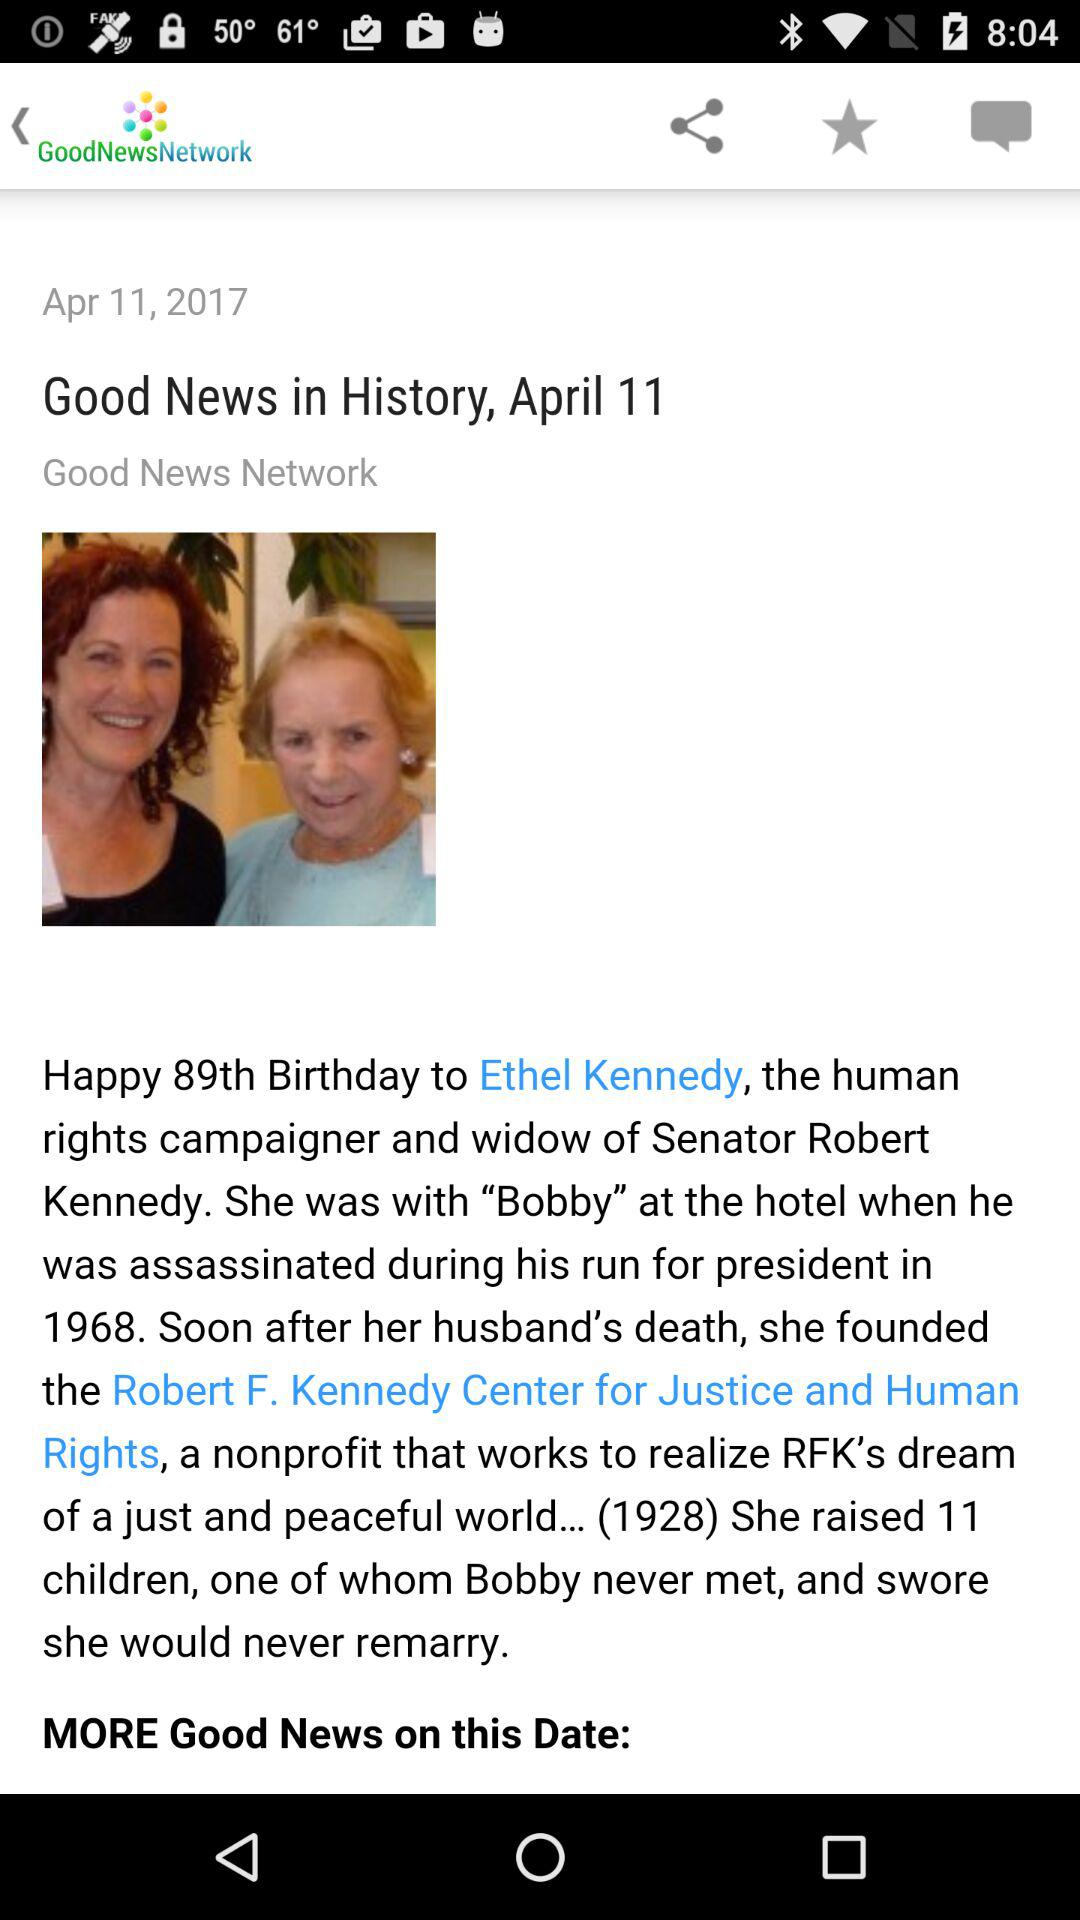What is the application name? The application name is "GoodNewsNetwork". 